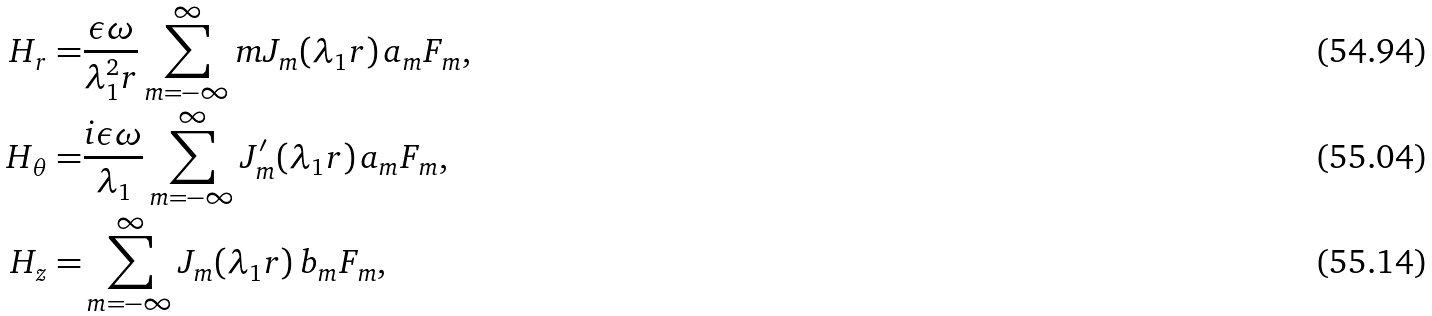<formula> <loc_0><loc_0><loc_500><loc_500>H _ { r } = & \frac { \epsilon \omega } { \lambda _ { 1 } ^ { 2 } r } \sum _ { m = - \infty } ^ { \infty } m J _ { m } ( \lambda _ { 1 } r ) \, a _ { m } F _ { m } , \\ H _ { \theta } = & \frac { i \epsilon \omega } { \lambda _ { 1 } } \sum _ { m = - \infty } ^ { \infty } J _ { m } ^ { \prime } ( \lambda _ { 1 } r ) \, a _ { m } F _ { m } , \\ H _ { z } = & \sum _ { m = - \infty } ^ { \infty } J _ { m } ( \lambda _ { 1 } r ) \, b _ { m } F _ { m } ,</formula> 